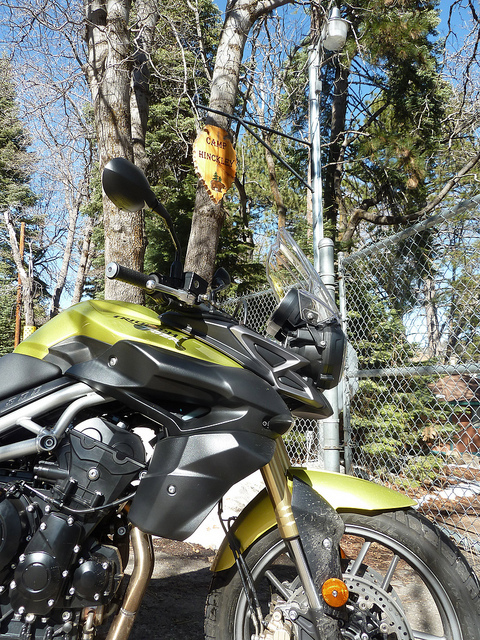Extract all visible text content from this image. HENCKLEY 